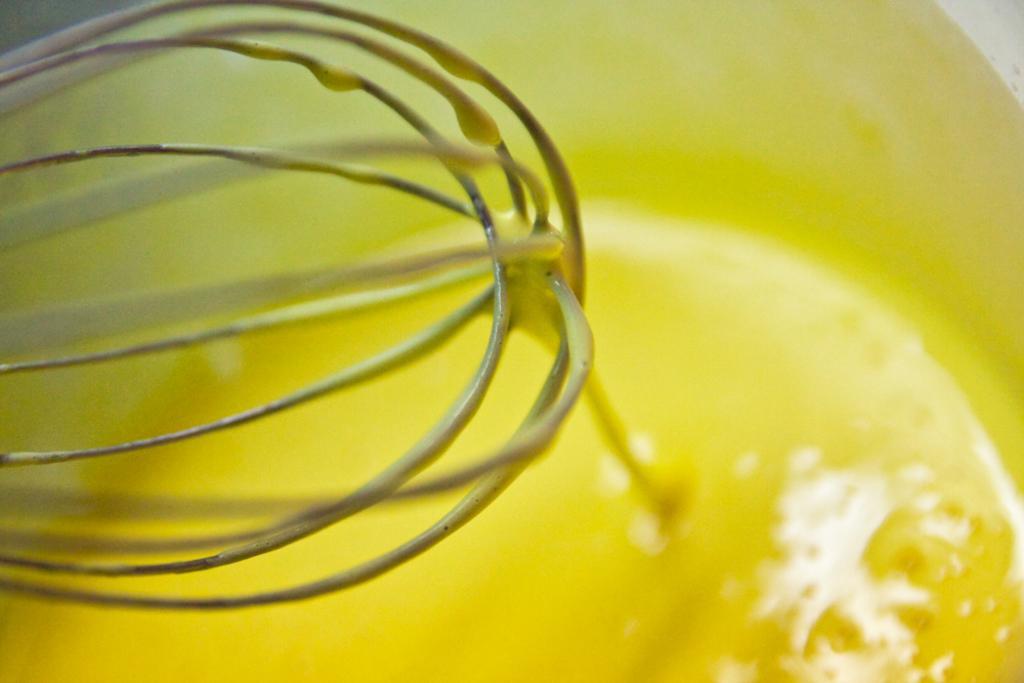In one or two sentences, can you explain what this image depicts? In the image we can see a container and in the container we can see the liquid, yellow in color and here we can see the metal object. 